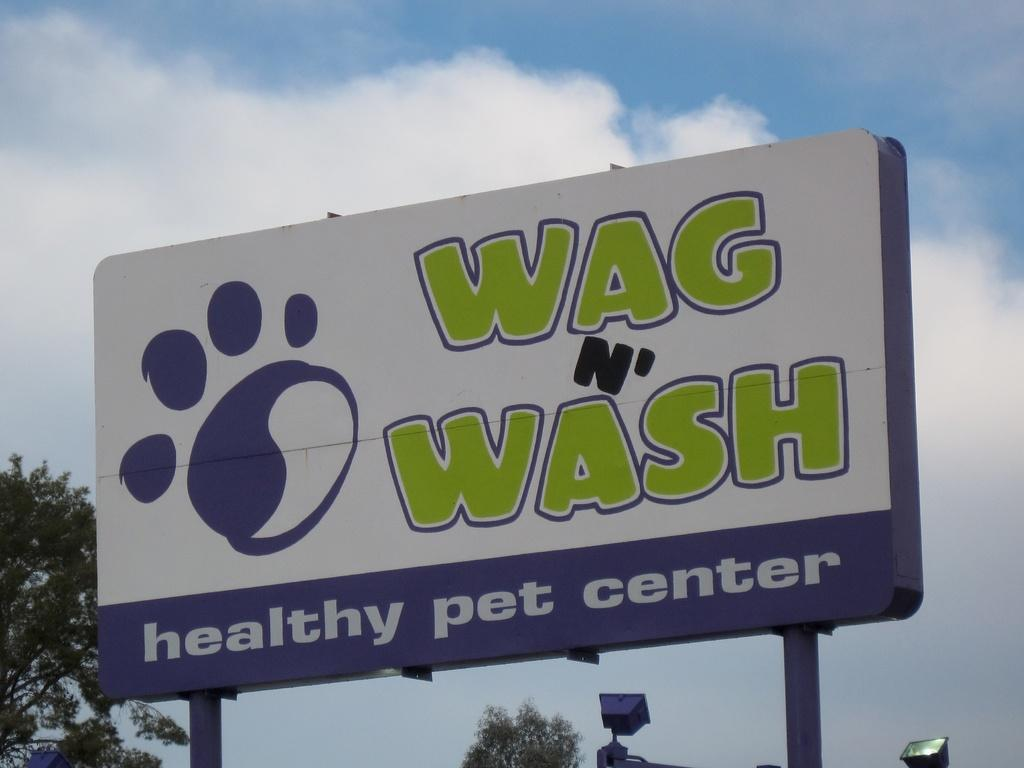<image>
Offer a succinct explanation of the picture presented. White and purple billboard with a paw print that says "Wag n' Wash". 